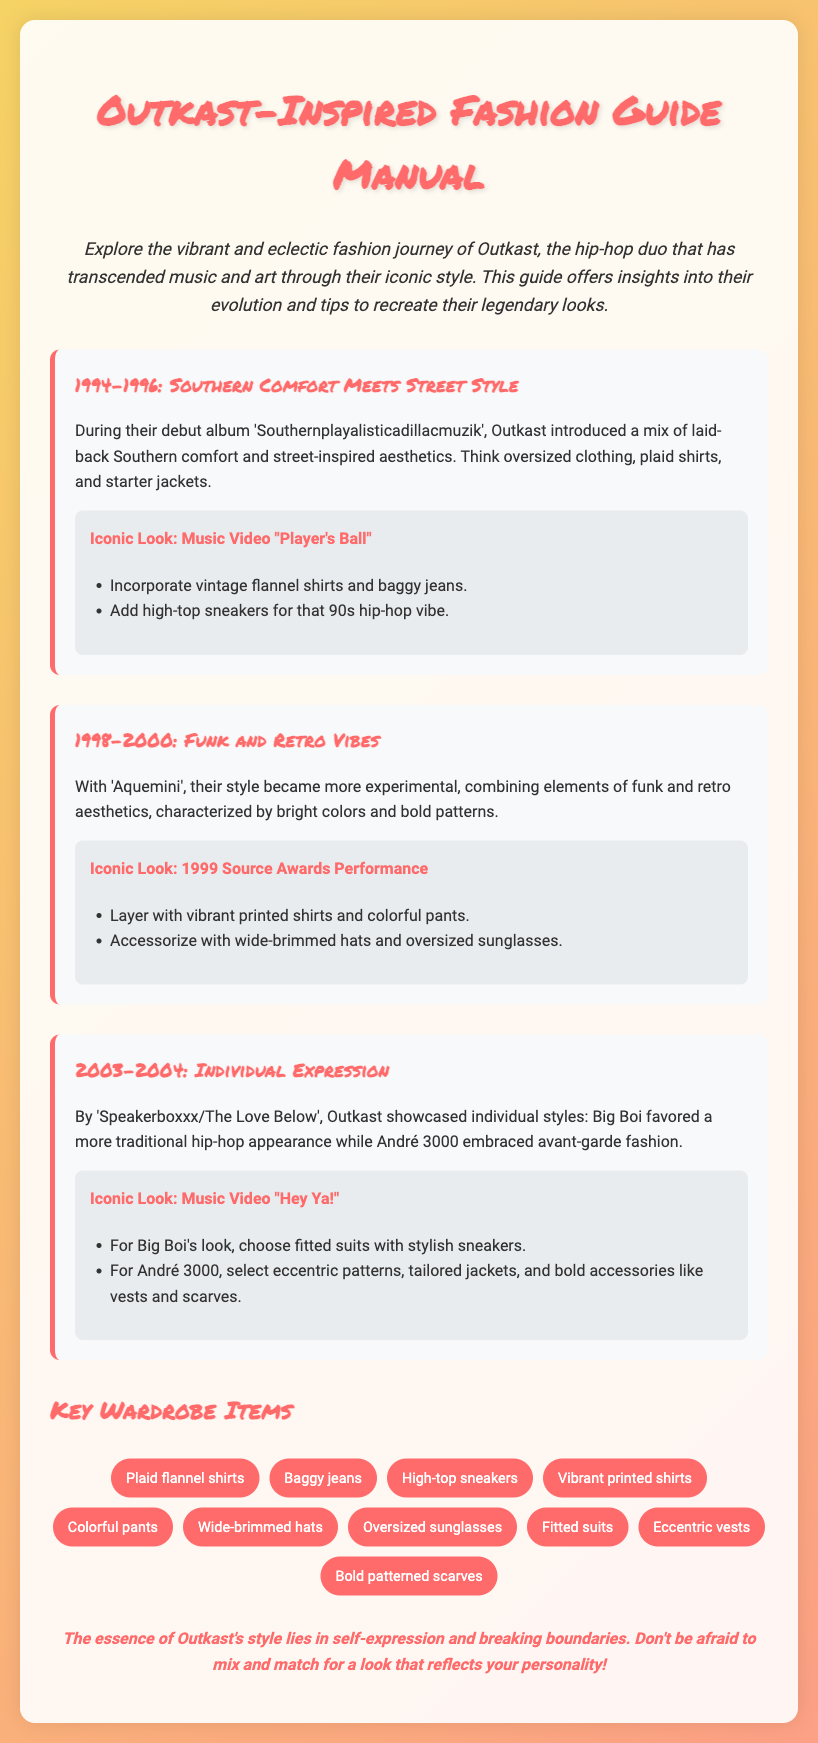What years does the first style era cover? The first style era mentioned is from 1994 to 1996.
Answer: 1994-1996 What is an iconic look from the "Player's Ball" music video? The guide suggests incorporating vintage flannel shirts and baggy jeans for this look.
Answer: Vintage flannel shirts and baggy jeans What type of headwear is recommended for the Source Awards performance look? The guide suggests accessorizing with wide-brimmed hats.
Answer: Wide-brimmed hats Which Outkast album marks the shift to individual expression in their fashion? The album mentioned is 'Speakerboxxx/The Love Below'.
Answer: Speakerboxxx/The Love Below How many key wardrobe items are listed in the document? The document lists a total of ten key wardrobe items for recreating Outkast's style.
Answer: Ten What fashion item is recommended for Big Boi’s iconic look in "Hey Ya!"? The guide recommends fitted suits for Big Boi's look.
Answer: Fitted suits Which patterns are suggested for André 3000's iconic style? The guide suggests eccentric patterns and tailored jackets for André 3000's look.
Answer: Eccentric patterns What is the main theme emphasized in Outkast's style according to the final remark? The essence of Outkast's style is self-expression and breaking boundaries.
Answer: Self-expression and breaking boundaries 